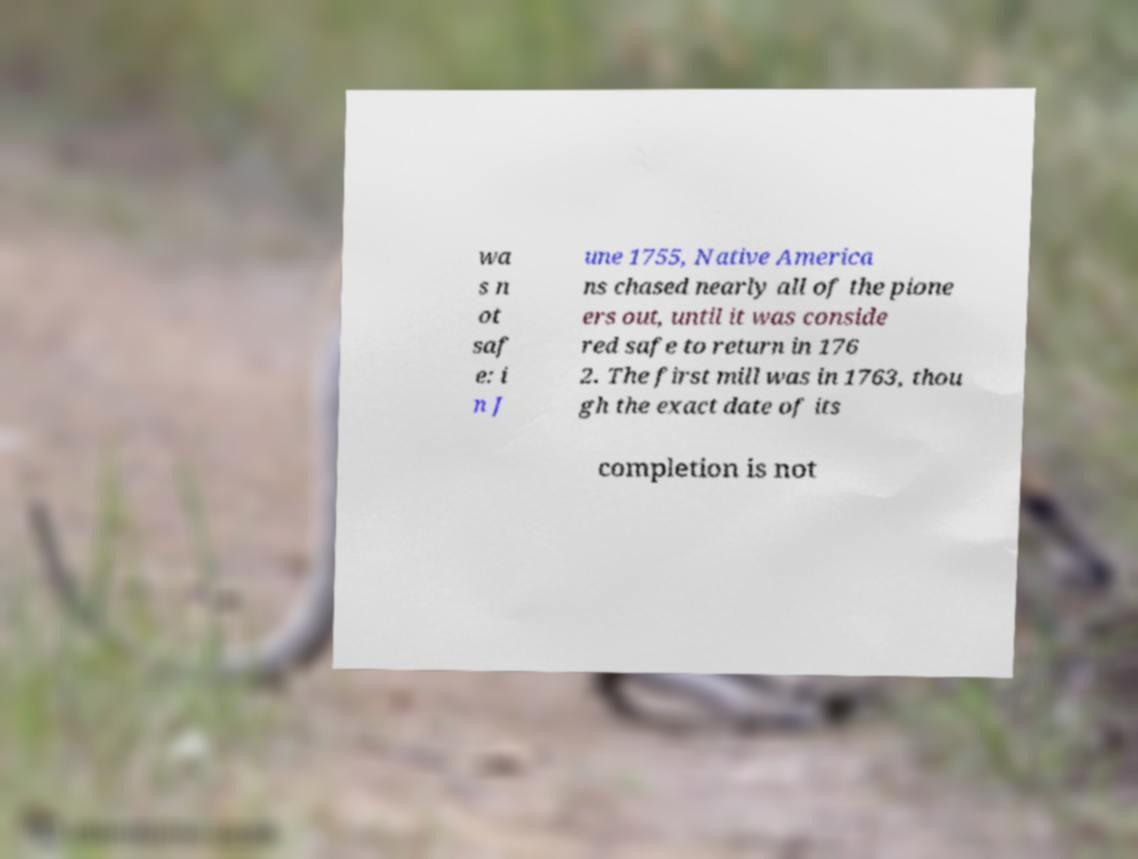Could you assist in decoding the text presented in this image and type it out clearly? wa s n ot saf e: i n J une 1755, Native America ns chased nearly all of the pione ers out, until it was conside red safe to return in 176 2. The first mill was in 1763, thou gh the exact date of its completion is not 